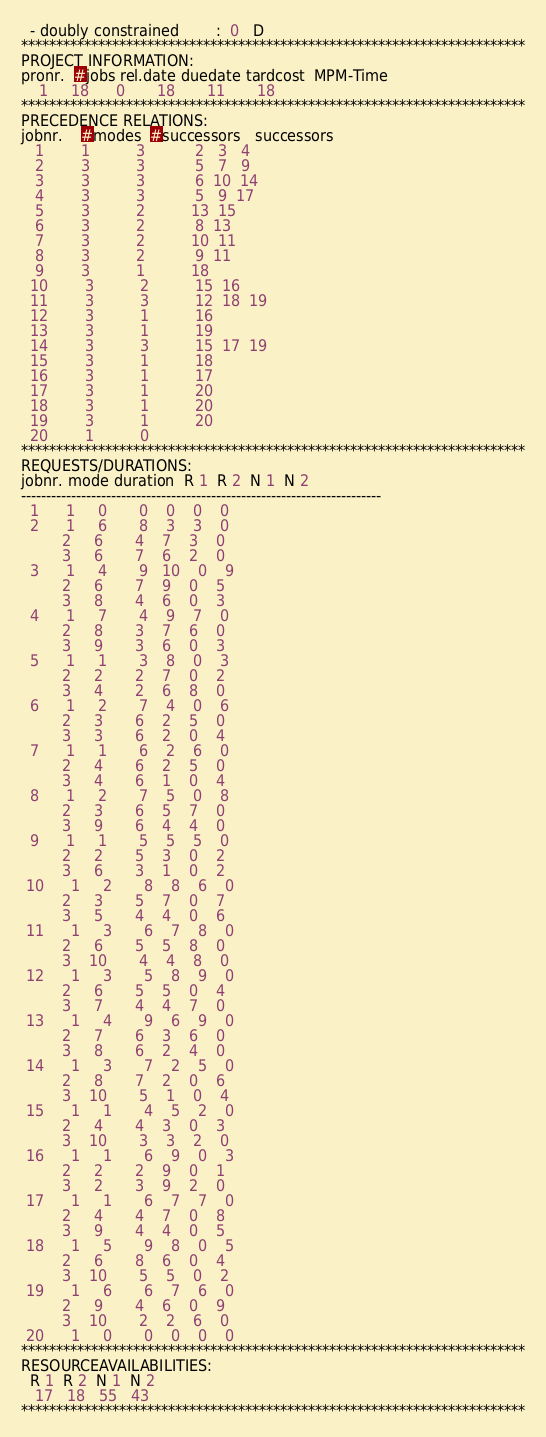Convert code to text. <code><loc_0><loc_0><loc_500><loc_500><_ObjectiveC_>  - doubly constrained        :  0   D
************************************************************************
PROJECT INFORMATION:
pronr.  #jobs rel.date duedate tardcost  MPM-Time
    1     18      0       18       11       18
************************************************************************
PRECEDENCE RELATIONS:
jobnr.    #modes  #successors   successors
   1        1          3           2   3   4
   2        3          3           5   7   9
   3        3          3           6  10  14
   4        3          3           5   9  17
   5        3          2          13  15
   6        3          2           8  13
   7        3          2          10  11
   8        3          2           9  11
   9        3          1          18
  10        3          2          15  16
  11        3          3          12  18  19
  12        3          1          16
  13        3          1          19
  14        3          3          15  17  19
  15        3          1          18
  16        3          1          17
  17        3          1          20
  18        3          1          20
  19        3          1          20
  20        1          0        
************************************************************************
REQUESTS/DURATIONS:
jobnr. mode duration  R 1  R 2  N 1  N 2
------------------------------------------------------------------------
  1      1     0       0    0    0    0
  2      1     6       8    3    3    0
         2     6       4    7    3    0
         3     6       7    6    2    0
  3      1     4       9   10    0    9
         2     6       7    9    0    5
         3     8       4    6    0    3
  4      1     7       4    9    7    0
         2     8       3    7    6    0
         3     9       3    6    0    3
  5      1     1       3    8    0    3
         2     2       2    7    0    2
         3     4       2    6    8    0
  6      1     2       7    4    0    6
         2     3       6    2    5    0
         3     3       6    2    0    4
  7      1     1       6    2    6    0
         2     4       6    2    5    0
         3     4       6    1    0    4
  8      1     2       7    5    0    8
         2     3       6    5    7    0
         3     9       6    4    4    0
  9      1     1       5    5    5    0
         2     2       5    3    0    2
         3     6       3    1    0    2
 10      1     2       8    8    6    0
         2     3       5    7    0    7
         3     5       4    4    0    6
 11      1     3       6    7    8    0
         2     6       5    5    8    0
         3    10       4    4    8    0
 12      1     3       5    8    9    0
         2     6       5    5    0    4
         3     7       4    4    7    0
 13      1     4       9    6    9    0
         2     7       6    3    6    0
         3     8       6    2    4    0
 14      1     3       7    2    5    0
         2     8       7    2    0    6
         3    10       5    1    0    4
 15      1     1       4    5    2    0
         2     4       4    3    0    3
         3    10       3    3    2    0
 16      1     1       6    9    0    3
         2     2       2    9    0    1
         3     2       3    9    2    0
 17      1     1       6    7    7    0
         2     4       4    7    0    8
         3     9       4    4    0    5
 18      1     5       9    8    0    5
         2     6       8    6    0    4
         3    10       5    5    0    2
 19      1     6       6    7    6    0
         2     9       4    6    0    9
         3    10       2    2    6    0
 20      1     0       0    0    0    0
************************************************************************
RESOURCEAVAILABILITIES:
  R 1  R 2  N 1  N 2
   17   18   55   43
************************************************************************
</code> 